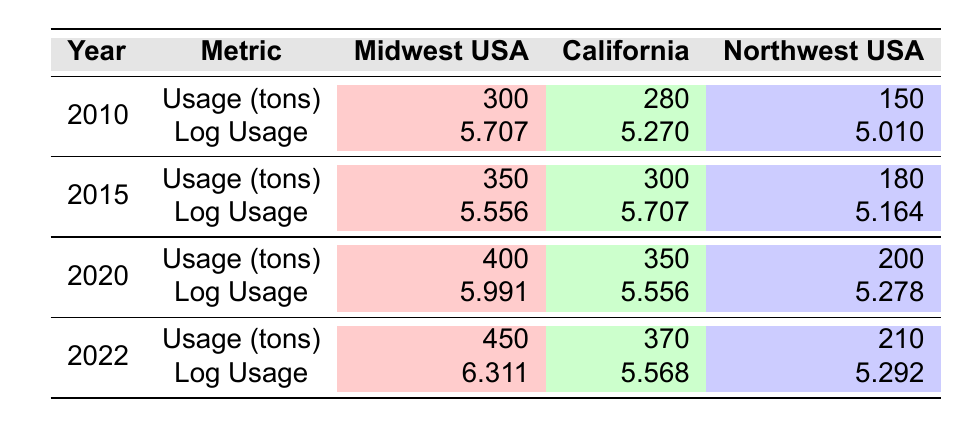What was the pesticide usage in tons for the Midwest USA in 2022? The table shows that for the Midwest USA in the year 2022, the usage in tons is listed in the row for that year. The corresponding value is 450 tons.
Answer: 450 What is the logarithmic value of pesticide usage for California in 2015? Referring to the table, we can locate California and the year 2015 to find the log usage value. The log usage for California in 2015 is 5.707.
Answer: 5.707 Which region had the highest log usage in 2020? In the year 2020, we compare the log usage for all regions: Midwest USA (5.991), California (5.556), and Northwest USA (5.278). The highest log usage is for the Midwest USA.
Answer: Midwest USA Is the pesticide usage in tons for the Northwest USA increasing or decreasing from 2010 to 2022? By observing the yearly usage for the Northwest USA: 150 tons in 2010, 180 tons in 2015, 200 tons in 2020, and 210 tons in 2022, we can see that the values are consistently rising, indicating an increase over time.
Answer: Yes What is the difference in log usage between the Midwest USA in 2022 and California in 2022? We find the log usage for the Midwest USA in 2022 is 6.311 and for California in 2022 is 5.568. The difference is calculated by subtracting California's log usage from Midwest's, yielding 6.311 - 5.568 = 0.743.
Answer: 0.743 Which region consistently had the lowest log usage throughout the provided years? We need to examine the log usage across all years for each region. The log usages for all regions are as follows: Midwest USA has values ranging from 5.556 to 6.311, California ranges from 5.270 to 5.707, and Northwest USA ranges from 5.010 to 5.292. The Northwest USA consistently has the lowest values during all years.
Answer: Northwest USA What was the total pesticide usage in tons for California from 2010 to 2022? We sum the yearly pesticide usage for California: 280 (2010) + 300 (2015) + 350 (2020) + 370 (2022) = 1300 tons.
Answer: 1300 Is the log usage for California in 2022 higher than in 2015? The log usage for California in 2022 is 5.568, and in 2015 it is 5.707. Since 5.568 is less than 5.707, the log usage in 2022 is not higher than in 2015.
Answer: No 